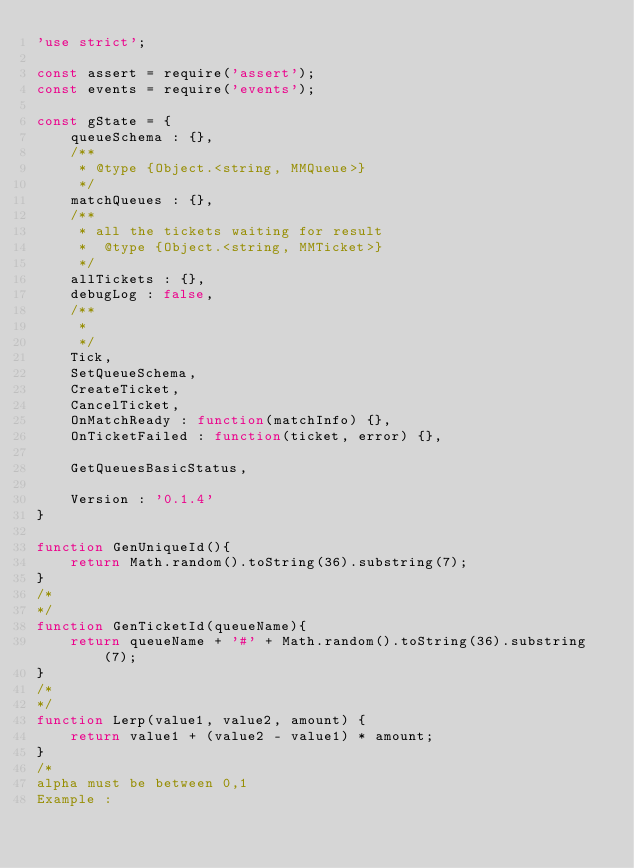Convert code to text. <code><loc_0><loc_0><loc_500><loc_500><_JavaScript_>'use strict';

const assert = require('assert');
const events = require('events');

const gState = {
    queueSchema : {},
    /**
     * @type {Object.<string, MMQueue>}
     */
    matchQueues : {},
    /**
     * all the tickets waiting for result
     *  @type {Object.<string, MMTicket>}
     */
    allTickets : {},
    debugLog : false,
    /**
     * 
     */
    Tick,
    SetQueueSchema,
    CreateTicket,
    CancelTicket,
    OnMatchReady : function(matchInfo) {},
    OnTicketFailed : function(ticket, error) {},

    GetQueuesBasicStatus,

    Version : '0.1.4'
}

function GenUniqueId(){
    return Math.random().toString(36).substring(7);
}
/*
*/
function GenTicketId(queueName){
    return queueName + '#' + Math.random().toString(36).substring(7);
}
/*
*/
function Lerp(value1, value2, amount) {
    return value1 + (value2 - value1) * amount;
}
/*
alpha must be between 0,1
Example :</code> 